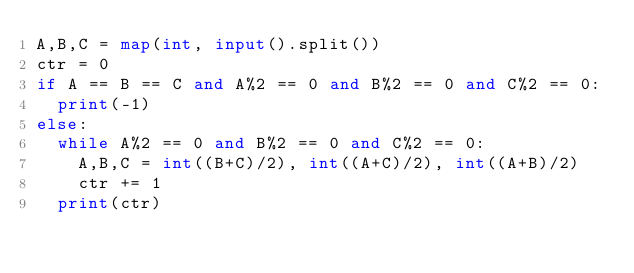<code> <loc_0><loc_0><loc_500><loc_500><_Python_>A,B,C = map(int, input().split())
ctr = 0
if A == B == C and A%2 == 0 and B%2 == 0 and C%2 == 0:
  print(-1)
else:
  while A%2 == 0 and B%2 == 0 and C%2 == 0:
    A,B,C = int((B+C)/2), int((A+C)/2), int((A+B)/2)
    ctr += 1
  print(ctr)</code> 